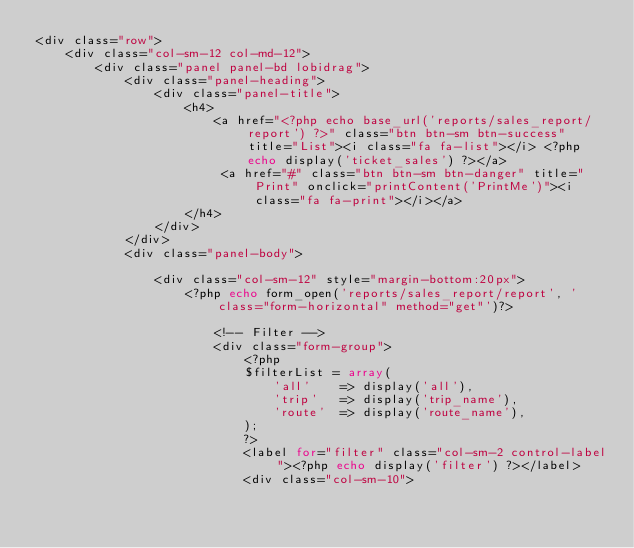Convert code to text. <code><loc_0><loc_0><loc_500><loc_500><_PHP_><div class="row">
    <div class="col-sm-12 col-md-12">
        <div class="panel panel-bd lobidrag">
            <div class="panel-heading">
                <div class="panel-title">
                    <h4>
                        <a href="<?php echo base_url('reports/sales_report/report') ?>" class="btn btn-sm btn-success" title="List"><i class="fa fa-list"></i> <?php echo display('ticket_sales') ?></a> 
                         <a href="#" class="btn btn-sm btn-danger" title="Print" onclick="printContent('PrintMe')"><i class="fa fa-print"></i></a>   
                    </h4>
                </div>
            </div>
            <div class="panel-body">

                <div class="col-sm-12" style="margin-bottom:20px">
                    <?php echo form_open('reports/sales_report/report', 'class="form-horizontal" method="get"')?>

                        <!-- Filter -->
                        <div class="form-group">
                            <?php 
                            $filterList = array(
                                'all'    => display('all'),
                                'trip'   => display('trip_name'),
                                'route'  => display('route_name'),
                            );
                            ?>
                            <label for="filter" class="col-sm-2 control-label"><?php echo display('filter') ?></label>
                            <div class="col-sm-10"></code> 